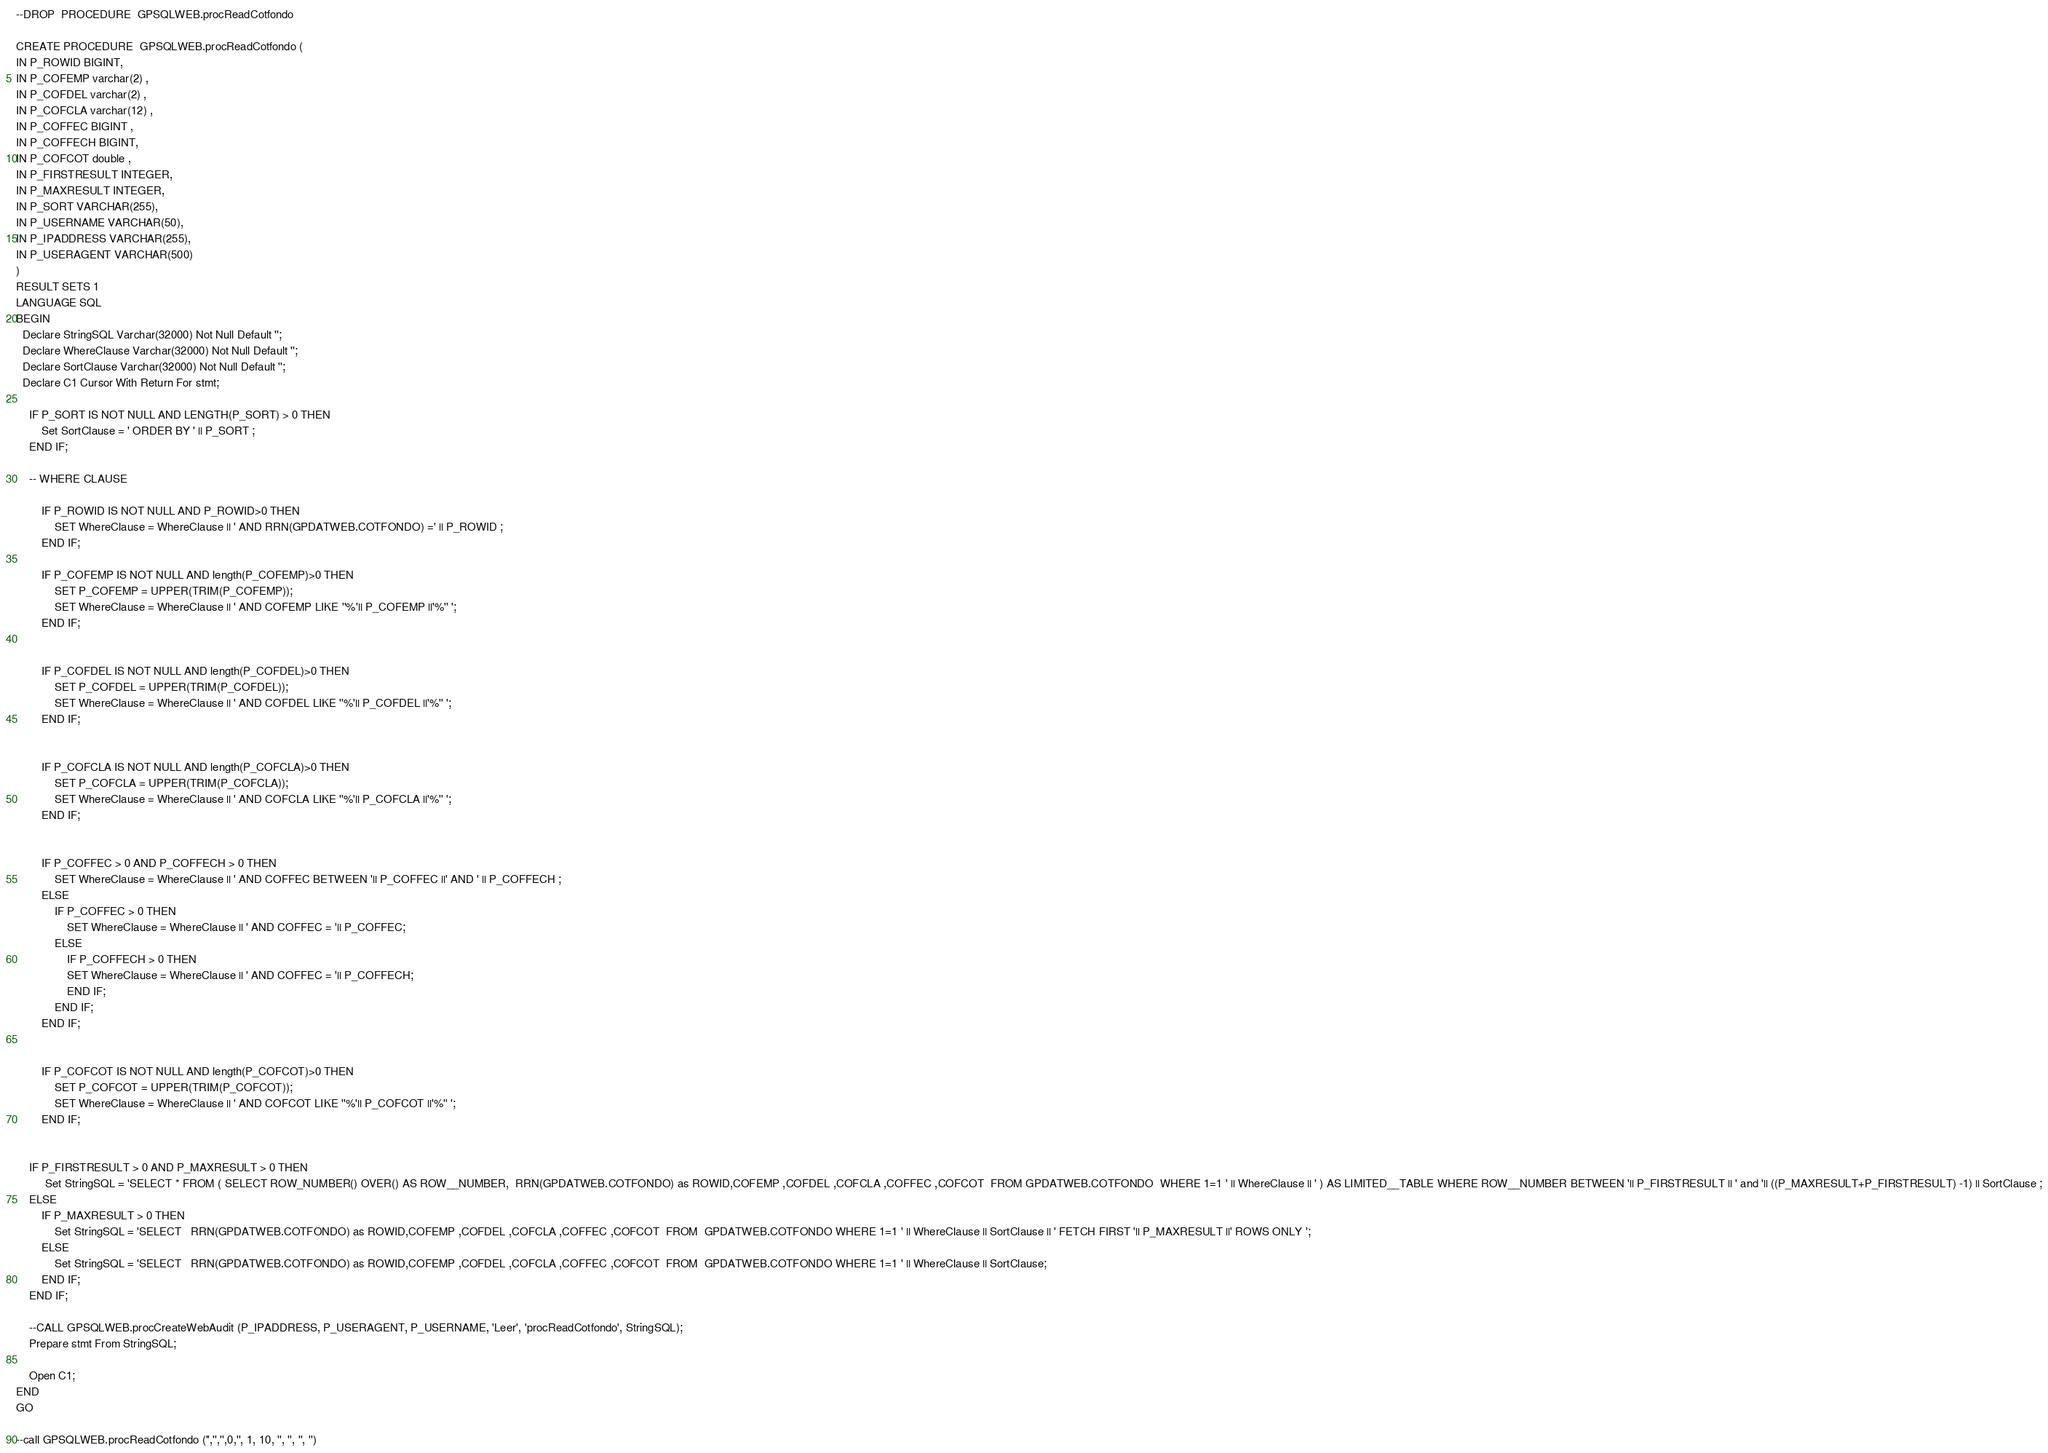Convert code to text. <code><loc_0><loc_0><loc_500><loc_500><_SQL_>

--DROP  PROCEDURE  GPSQLWEB.procReadCotfondo

CREATE PROCEDURE  GPSQLWEB.procReadCotfondo (
IN P_ROWID BIGINT,
IN P_COFEMP varchar(2) ,
IN P_COFDEL varchar(2) ,
IN P_COFCLA varchar(12) ,
IN P_COFFEC BIGINT ,
IN P_COFFECH BIGINT,
IN P_COFCOT double ,
IN P_FIRSTRESULT INTEGER,
IN P_MAXRESULT INTEGER,
IN P_SORT VARCHAR(255),
IN P_USERNAME VARCHAR(50),
IN P_IPADDRESS VARCHAR(255),
IN P_USERAGENT VARCHAR(500)
)
RESULT SETS 1
LANGUAGE SQL
BEGIN
  Declare StringSQL Varchar(32000) Not Null Default '';
  Declare WhereClause Varchar(32000) Not Null Default '';
  Declare SortClause Varchar(32000) Not Null Default '';
  Declare C1 Cursor With Return For stmt;

    IF P_SORT IS NOT NULL AND LENGTH(P_SORT) > 0 THEN
        Set SortClause = ' ORDER BY ' || P_SORT ;
    END IF;

    -- WHERE CLAUSE
    
        IF P_ROWID IS NOT NULL AND P_ROWID>0 THEN
            SET WhereClause = WhereClause || ' AND RRN(GPDATWEB.COTFONDO) =' || P_ROWID ;
        END IF;
        
        IF P_COFEMP IS NOT NULL AND length(P_COFEMP)>0 THEN
            SET P_COFEMP = UPPER(TRIM(P_COFEMP));
            SET WhereClause = WhereClause || ' AND COFEMP LIKE ''%'|| P_COFEMP ||'%'' ';
        END IF;
    
        
        IF P_COFDEL IS NOT NULL AND length(P_COFDEL)>0 THEN
            SET P_COFDEL = UPPER(TRIM(P_COFDEL));
            SET WhereClause = WhereClause || ' AND COFDEL LIKE ''%'|| P_COFDEL ||'%'' ';
        END IF;
    
        
        IF P_COFCLA IS NOT NULL AND length(P_COFCLA)>0 THEN
            SET P_COFCLA = UPPER(TRIM(P_COFCLA));
            SET WhereClause = WhereClause || ' AND COFCLA LIKE ''%'|| P_COFCLA ||'%'' ';
        END IF;
    
        
        IF P_COFFEC > 0 AND P_COFFECH > 0 THEN
            SET WhereClause = WhereClause || ' AND COFFEC BETWEEN '|| P_COFFEC ||' AND ' || P_COFFECH ;
        ELSE
            IF P_COFFEC > 0 THEN
                SET WhereClause = WhereClause || ' AND COFFEC = '|| P_COFFEC;
            ELSE
                IF P_COFFECH > 0 THEN
                SET WhereClause = WhereClause || ' AND COFFEC = '|| P_COFFECH;
                END IF;
            END IF;
        END IF;
    
        
        IF P_COFCOT IS NOT NULL AND length(P_COFCOT)>0 THEN
            SET P_COFCOT = UPPER(TRIM(P_COFCOT));
            SET WhereClause = WhereClause || ' AND COFCOT LIKE ''%'|| P_COFCOT ||'%'' ';
        END IF;
    

    IF P_FIRSTRESULT > 0 AND P_MAXRESULT > 0 THEN
         Set StringSQL = 'SELECT * FROM ( SELECT ROW_NUMBER() OVER() AS ROW__NUMBER,  RRN(GPDATWEB.COTFONDO) as ROWID,COFEMP ,COFDEL ,COFCLA ,COFFEC ,COFCOT  FROM GPDATWEB.COTFONDO  WHERE 1=1 ' || WhereClause || ' ) AS LIMITED__TABLE WHERE ROW__NUMBER BETWEEN '|| P_FIRSTRESULT || ' and '|| ((P_MAXRESULT+P_FIRSTRESULT) -1) || SortClause ;
    ELSE
        IF P_MAXRESULT > 0 THEN
            Set StringSQL = 'SELECT   RRN(GPDATWEB.COTFONDO) as ROWID,COFEMP ,COFDEL ,COFCLA ,COFFEC ,COFCOT  FROM  GPDATWEB.COTFONDO WHERE 1=1 ' || WhereClause || SortClause || ' FETCH FIRST '|| P_MAXRESULT ||' ROWS ONLY '; 
        ELSE
            Set StringSQL = 'SELECT   RRN(GPDATWEB.COTFONDO) as ROWID,COFEMP ,COFDEL ,COFCLA ,COFFEC ,COFCOT  FROM  GPDATWEB.COTFONDO WHERE 1=1 ' || WhereClause || SortClause; 
        END IF;
    END IF;

    --CALL GPSQLWEB.procCreateWebAudit (P_IPADDRESS, P_USERAGENT, P_USERNAME, 'Leer', 'procReadCotfondo', StringSQL);
    Prepare stmt From StringSQL; 
    
    Open C1; 
END
GO

--call GPSQLWEB.procReadCotfondo ('','','',0,'', 1, 10, '', '', '', '')
</code> 